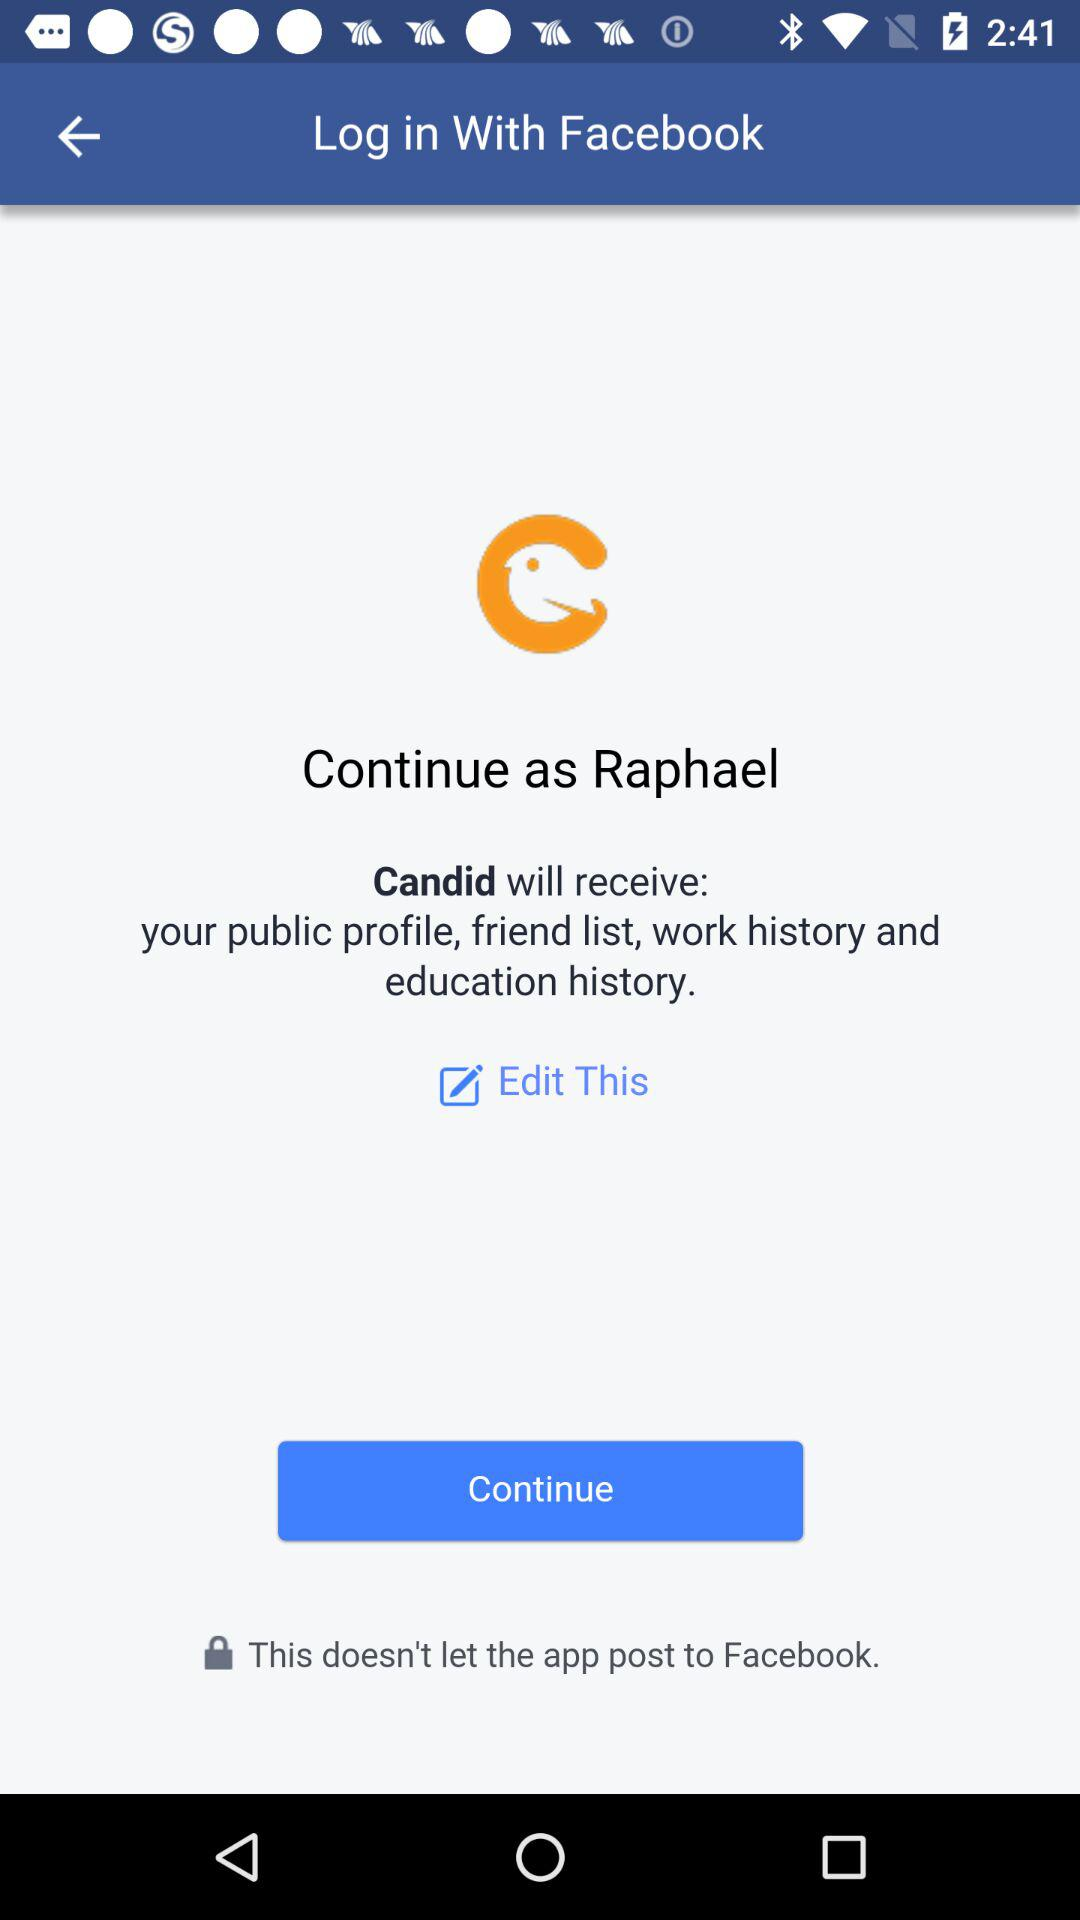What application is asking for permission? The application "Candid" is asking for permission. 